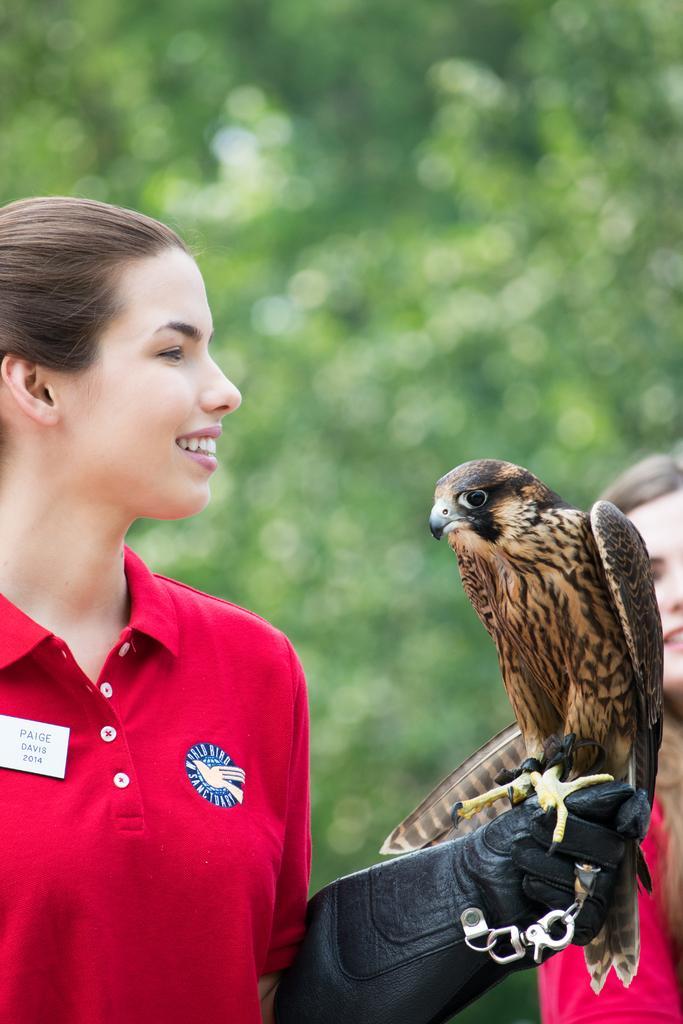Can you describe this image briefly? Here we can see two women and there is a bird on the glove. There is a blur background with greenery. 